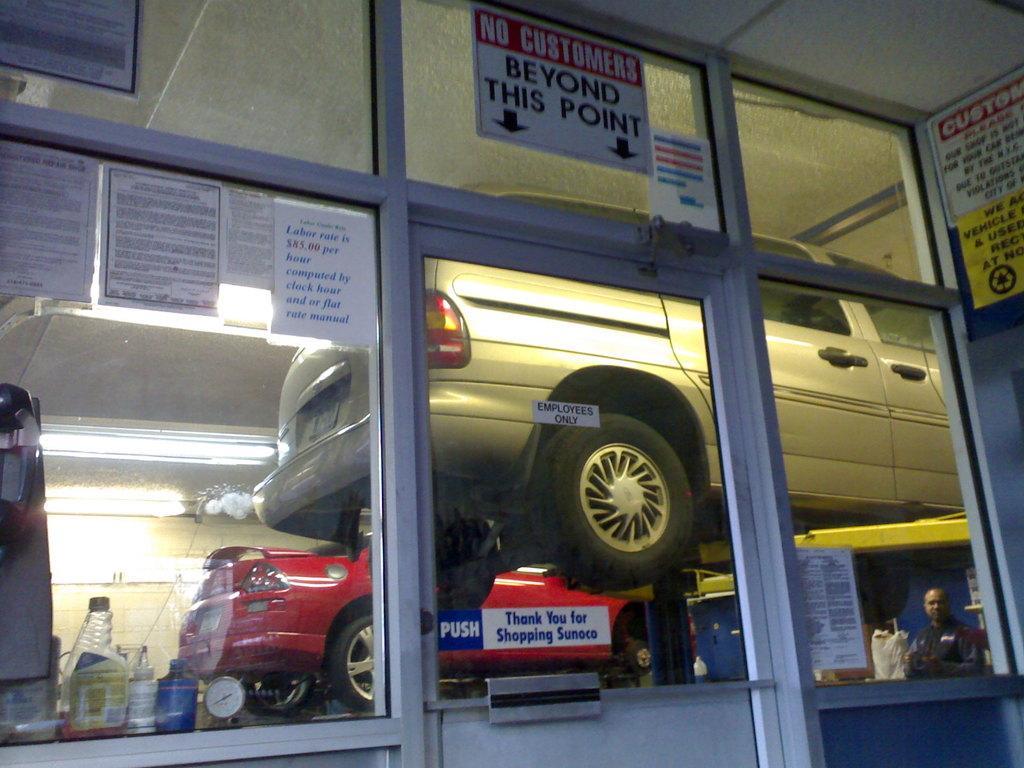Describe this image in one or two sentences. In this picture we can see posters on the glass doors, from the glass we can see vehicles, person, clock, bottles, lights and some objects and we can see a wall in the background. 